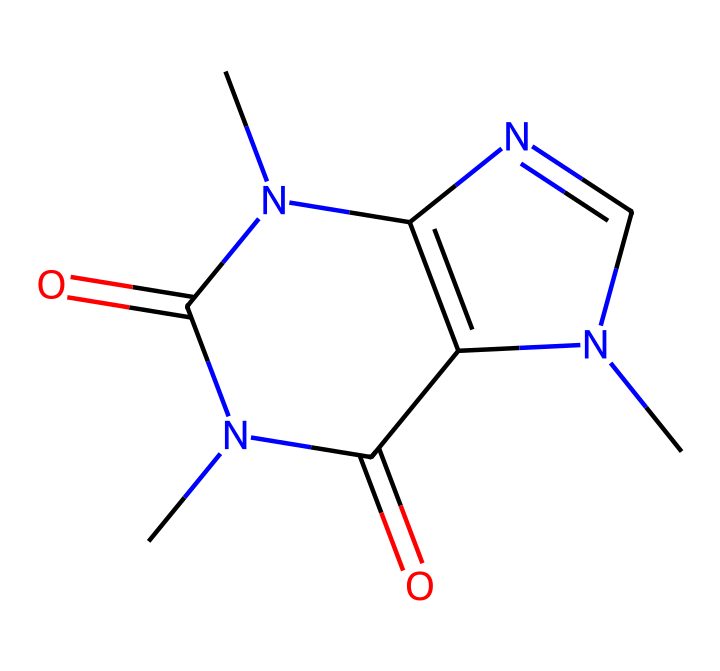What is the molecular formula of this compound? To find the molecular formula, count the number of each type of atom present in the SMILES. The SMILES represents 8 carbon atoms, 10 hydrogen atoms, 4 nitrogen atoms, and 2 oxygen atoms. Thus, the molecular formula is C8H10N4O2.
Answer: C8H10N4O2 How many rings are present in the structure? By analyzing the SMILES notation, we can see that there are two ring indicators (N1 and N2). Therefore, there are two distinct rings formed in this cage compound structure.
Answer: 2 Is this compound a stimulant? Given that caffeine is known to be a stimulant, and this compound is the structure of caffeine derived from the provided SMILES, it can be inferred that it possesses stimulant properties.
Answer: Yes How many nitrogen atoms are in the structure? Reviewing the SMILES, identify all the instances of 'N', which shows that there are four nitrogen atoms attached to different parts of the molecule. The count proves to be four.
Answer: 4 What type of compound is this molecule classified as? Based on the structure featuring nitrogen atoms and a cage-like formation, coupled with its stimulating properties, this compound can be classified as an alkaloid.
Answer: alkaloid What functional groups are present in this compound? Analyze the SMILES for specific functional groups, such as amines (NH) and carbonyls (C=O). The presence of these groups suggests functionalities common in alkaloids like caffeine. The functional groups identified here are amine and carbonyl.
Answer: amine and carbonyl How many double bonds are in the structure? By closely inspecting the connections in the SMILES, it can be observed there are two double bonds (the two carbonyls), indicating there are a total of two double bonds in the molecular framework.
Answer: 2 